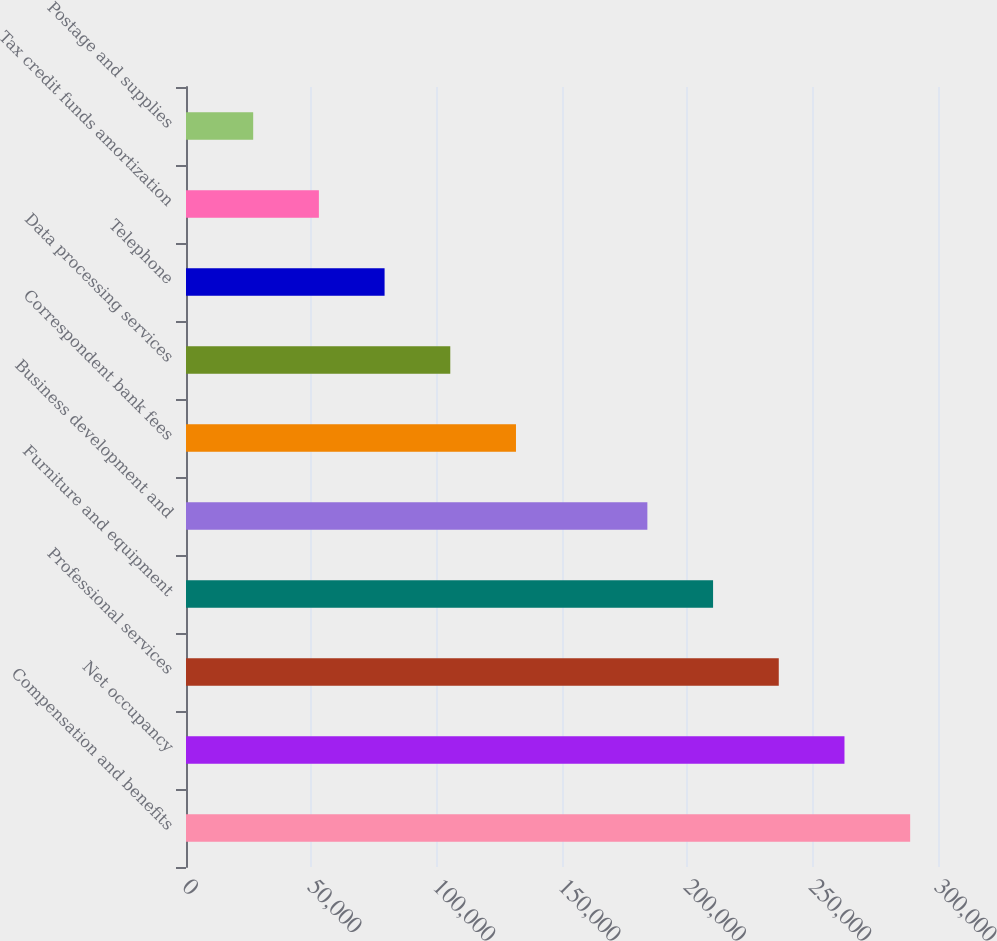<chart> <loc_0><loc_0><loc_500><loc_500><bar_chart><fcel>Compensation and benefits<fcel>Net occupancy<fcel>Professional services<fcel>Furniture and equipment<fcel>Business development and<fcel>Correspondent bank fees<fcel>Data processing services<fcel>Telephone<fcel>Tax credit funds amortization<fcel>Postage and supplies<nl><fcel>288896<fcel>262687<fcel>236478<fcel>210268<fcel>184059<fcel>131640<fcel>105431<fcel>79221.9<fcel>53012.6<fcel>26803.3<nl></chart> 